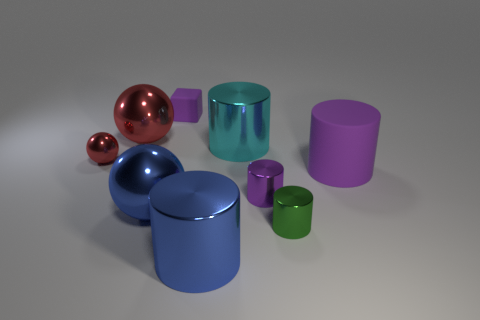Subtract 2 cylinders. How many cylinders are left? 3 Subtract all cyan cylinders. How many cylinders are left? 4 Subtract all large blue cylinders. How many cylinders are left? 4 Subtract all cyan cubes. Subtract all yellow spheres. How many cubes are left? 1 Add 1 tiny green shiny cylinders. How many objects exist? 10 Subtract all cylinders. How many objects are left? 4 Subtract 0 red cylinders. How many objects are left? 9 Subtract all red blocks. Subtract all tiny purple cylinders. How many objects are left? 8 Add 1 small red things. How many small red things are left? 2 Add 5 big blue metallic things. How many big blue metallic things exist? 7 